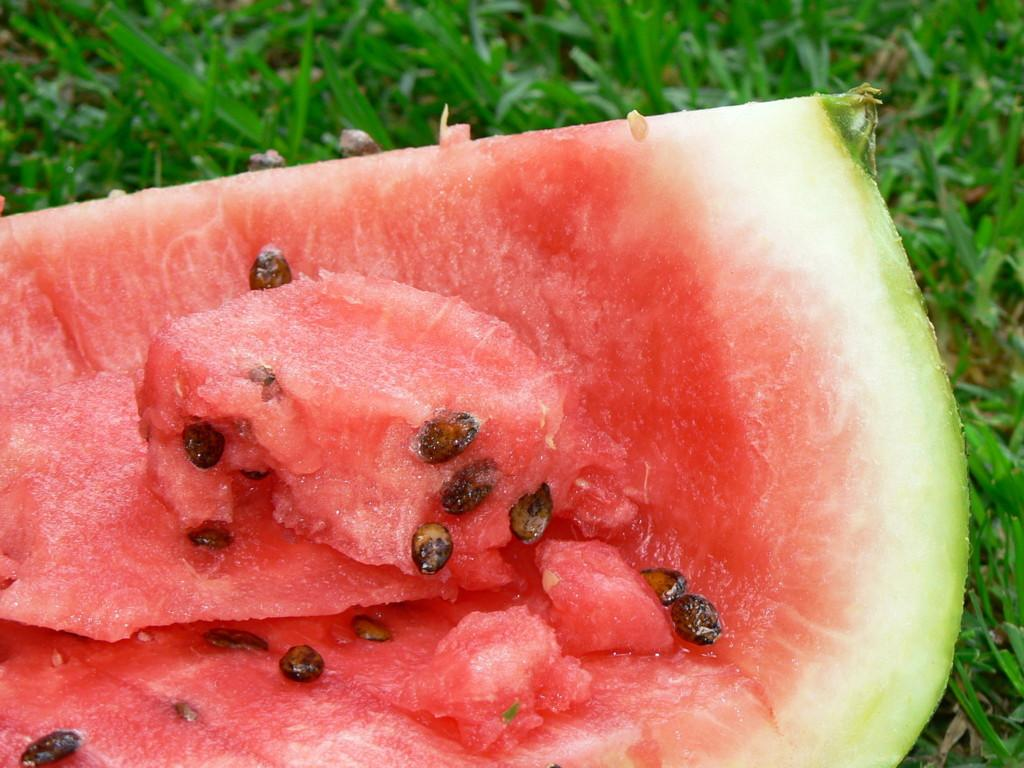What is the main object in the image? There is a watermelon in the image. Where is the watermelon located? The watermelon is on the grass. What type of soda is being poured over the watermelon in the image? There is no soda present in the image; it only features a watermelon on the grass. 